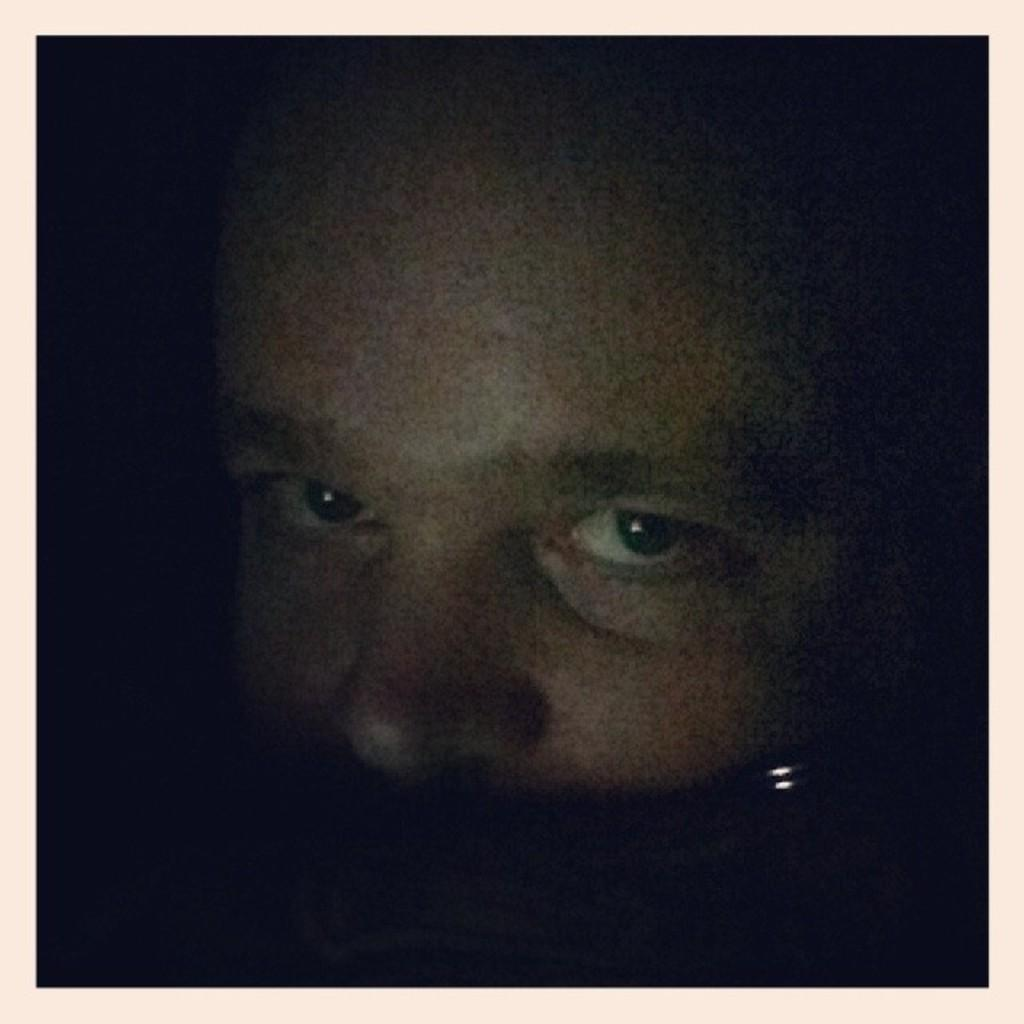What type of editing has been done to the image? The image is edited. What can be seen in the image after the editing? The face of a person is visible in the image. How would you describe the background of the image? The background of the image looks dark. Can you see any popcorn floating around the person's face in the image? There is no popcorn visible in the image. Are there any fairies present in the image? There are no fairies present in the image. 